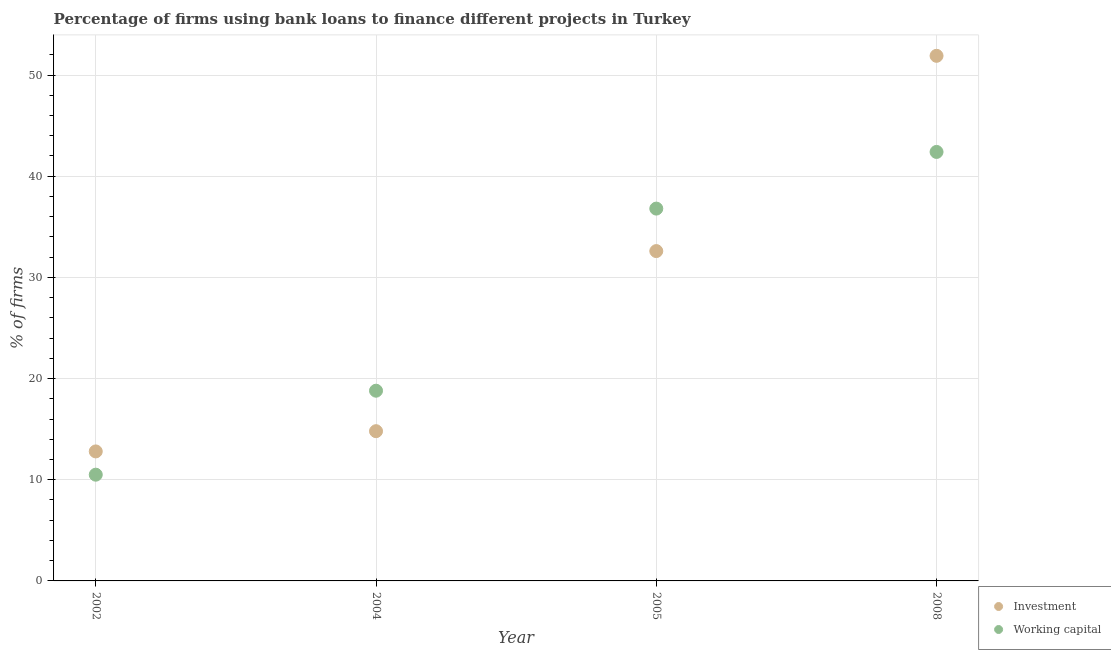How many different coloured dotlines are there?
Provide a short and direct response. 2. Across all years, what is the maximum percentage of firms using banks to finance working capital?
Make the answer very short. 42.4. In which year was the percentage of firms using banks to finance working capital maximum?
Offer a terse response. 2008. In which year was the percentage of firms using banks to finance working capital minimum?
Your answer should be compact. 2002. What is the total percentage of firms using banks to finance working capital in the graph?
Provide a short and direct response. 108.5. What is the difference between the percentage of firms using banks to finance investment in 2002 and that in 2008?
Give a very brief answer. -39.1. What is the difference between the percentage of firms using banks to finance working capital in 2002 and the percentage of firms using banks to finance investment in 2004?
Keep it short and to the point. -4.3. What is the average percentage of firms using banks to finance investment per year?
Make the answer very short. 28.02. In the year 2005, what is the difference between the percentage of firms using banks to finance investment and percentage of firms using banks to finance working capital?
Provide a succinct answer. -4.2. What is the ratio of the percentage of firms using banks to finance investment in 2002 to that in 2008?
Offer a very short reply. 0.25. What is the difference between the highest and the second highest percentage of firms using banks to finance investment?
Ensure brevity in your answer.  19.3. What is the difference between the highest and the lowest percentage of firms using banks to finance working capital?
Give a very brief answer. 31.9. In how many years, is the percentage of firms using banks to finance working capital greater than the average percentage of firms using banks to finance working capital taken over all years?
Your answer should be very brief. 2. Does the percentage of firms using banks to finance investment monotonically increase over the years?
Your answer should be very brief. Yes. Is the percentage of firms using banks to finance working capital strictly greater than the percentage of firms using banks to finance investment over the years?
Your response must be concise. No. Is the percentage of firms using banks to finance working capital strictly less than the percentage of firms using banks to finance investment over the years?
Your response must be concise. No. How many years are there in the graph?
Offer a terse response. 4. Does the graph contain any zero values?
Your answer should be very brief. No. Does the graph contain grids?
Ensure brevity in your answer.  Yes. Where does the legend appear in the graph?
Provide a short and direct response. Bottom right. How many legend labels are there?
Ensure brevity in your answer.  2. What is the title of the graph?
Keep it short and to the point. Percentage of firms using bank loans to finance different projects in Turkey. What is the label or title of the Y-axis?
Provide a succinct answer. % of firms. What is the % of firms in Investment in 2002?
Make the answer very short. 12.8. What is the % of firms in Working capital in 2002?
Your answer should be compact. 10.5. What is the % of firms in Investment in 2004?
Provide a short and direct response. 14.8. What is the % of firms of Working capital in 2004?
Your answer should be compact. 18.8. What is the % of firms in Investment in 2005?
Provide a succinct answer. 32.6. What is the % of firms of Working capital in 2005?
Your response must be concise. 36.8. What is the % of firms of Investment in 2008?
Provide a short and direct response. 51.9. What is the % of firms of Working capital in 2008?
Your response must be concise. 42.4. Across all years, what is the maximum % of firms in Investment?
Offer a terse response. 51.9. Across all years, what is the maximum % of firms of Working capital?
Offer a very short reply. 42.4. What is the total % of firms of Investment in the graph?
Your response must be concise. 112.1. What is the total % of firms of Working capital in the graph?
Offer a very short reply. 108.5. What is the difference between the % of firms in Working capital in 2002 and that in 2004?
Your answer should be compact. -8.3. What is the difference between the % of firms in Investment in 2002 and that in 2005?
Keep it short and to the point. -19.8. What is the difference between the % of firms in Working capital in 2002 and that in 2005?
Provide a succinct answer. -26.3. What is the difference between the % of firms of Investment in 2002 and that in 2008?
Your answer should be compact. -39.1. What is the difference between the % of firms of Working capital in 2002 and that in 2008?
Provide a succinct answer. -31.9. What is the difference between the % of firms of Investment in 2004 and that in 2005?
Provide a succinct answer. -17.8. What is the difference between the % of firms of Investment in 2004 and that in 2008?
Provide a succinct answer. -37.1. What is the difference between the % of firms of Working capital in 2004 and that in 2008?
Ensure brevity in your answer.  -23.6. What is the difference between the % of firms in Investment in 2005 and that in 2008?
Your answer should be compact. -19.3. What is the difference between the % of firms of Working capital in 2005 and that in 2008?
Make the answer very short. -5.6. What is the difference between the % of firms in Investment in 2002 and the % of firms in Working capital in 2008?
Make the answer very short. -29.6. What is the difference between the % of firms in Investment in 2004 and the % of firms in Working capital in 2005?
Give a very brief answer. -22. What is the difference between the % of firms of Investment in 2004 and the % of firms of Working capital in 2008?
Provide a short and direct response. -27.6. What is the average % of firms of Investment per year?
Provide a short and direct response. 28.02. What is the average % of firms of Working capital per year?
Offer a terse response. 27.12. In the year 2005, what is the difference between the % of firms of Investment and % of firms of Working capital?
Your response must be concise. -4.2. What is the ratio of the % of firms of Investment in 2002 to that in 2004?
Provide a succinct answer. 0.86. What is the ratio of the % of firms in Working capital in 2002 to that in 2004?
Make the answer very short. 0.56. What is the ratio of the % of firms of Investment in 2002 to that in 2005?
Ensure brevity in your answer.  0.39. What is the ratio of the % of firms in Working capital in 2002 to that in 2005?
Your answer should be compact. 0.29. What is the ratio of the % of firms in Investment in 2002 to that in 2008?
Offer a very short reply. 0.25. What is the ratio of the % of firms of Working capital in 2002 to that in 2008?
Provide a short and direct response. 0.25. What is the ratio of the % of firms in Investment in 2004 to that in 2005?
Keep it short and to the point. 0.45. What is the ratio of the % of firms of Working capital in 2004 to that in 2005?
Keep it short and to the point. 0.51. What is the ratio of the % of firms in Investment in 2004 to that in 2008?
Make the answer very short. 0.29. What is the ratio of the % of firms of Working capital in 2004 to that in 2008?
Provide a succinct answer. 0.44. What is the ratio of the % of firms of Investment in 2005 to that in 2008?
Your answer should be very brief. 0.63. What is the ratio of the % of firms of Working capital in 2005 to that in 2008?
Your answer should be compact. 0.87. What is the difference between the highest and the second highest % of firms of Investment?
Ensure brevity in your answer.  19.3. What is the difference between the highest and the second highest % of firms of Working capital?
Offer a very short reply. 5.6. What is the difference between the highest and the lowest % of firms in Investment?
Your answer should be compact. 39.1. What is the difference between the highest and the lowest % of firms in Working capital?
Provide a succinct answer. 31.9. 